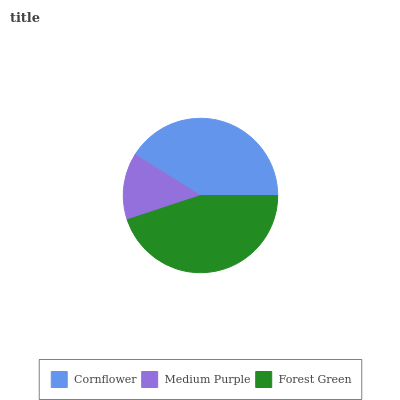Is Medium Purple the minimum?
Answer yes or no. Yes. Is Forest Green the maximum?
Answer yes or no. Yes. Is Forest Green the minimum?
Answer yes or no. No. Is Medium Purple the maximum?
Answer yes or no. No. Is Forest Green greater than Medium Purple?
Answer yes or no. Yes. Is Medium Purple less than Forest Green?
Answer yes or no. Yes. Is Medium Purple greater than Forest Green?
Answer yes or no. No. Is Forest Green less than Medium Purple?
Answer yes or no. No. Is Cornflower the high median?
Answer yes or no. Yes. Is Cornflower the low median?
Answer yes or no. Yes. Is Medium Purple the high median?
Answer yes or no. No. Is Medium Purple the low median?
Answer yes or no. No. 